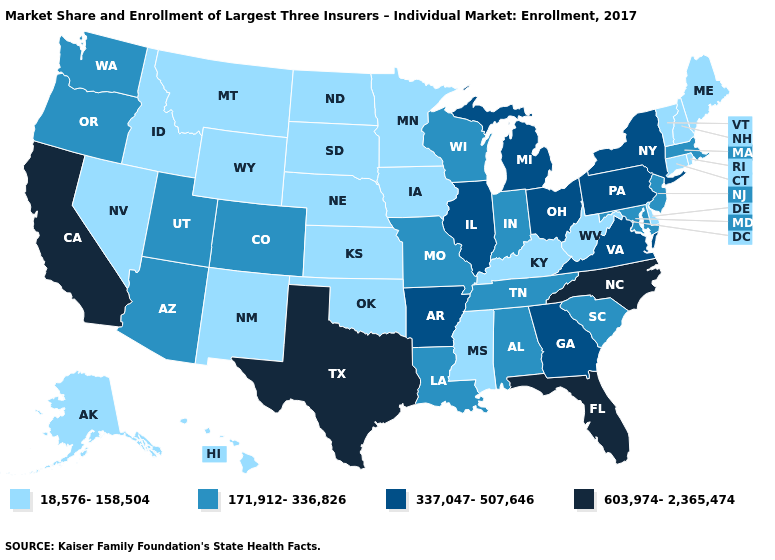Does the map have missing data?
Concise answer only. No. Does Kansas have the same value as California?
Short answer required. No. What is the highest value in states that border Arkansas?
Concise answer only. 603,974-2,365,474. Does Kansas have the highest value in the USA?
Give a very brief answer. No. Does North Carolina have the highest value in the USA?
Concise answer only. Yes. What is the value of Hawaii?
Quick response, please. 18,576-158,504. What is the lowest value in the Northeast?
Write a very short answer. 18,576-158,504. What is the value of Connecticut?
Concise answer only. 18,576-158,504. Which states have the lowest value in the West?
Short answer required. Alaska, Hawaii, Idaho, Montana, Nevada, New Mexico, Wyoming. What is the value of Oklahoma?
Keep it brief. 18,576-158,504. What is the lowest value in states that border Maine?
Short answer required. 18,576-158,504. What is the highest value in the MidWest ?
Answer briefly. 337,047-507,646. What is the highest value in the USA?
Give a very brief answer. 603,974-2,365,474. Which states have the highest value in the USA?
Answer briefly. California, Florida, North Carolina, Texas. 